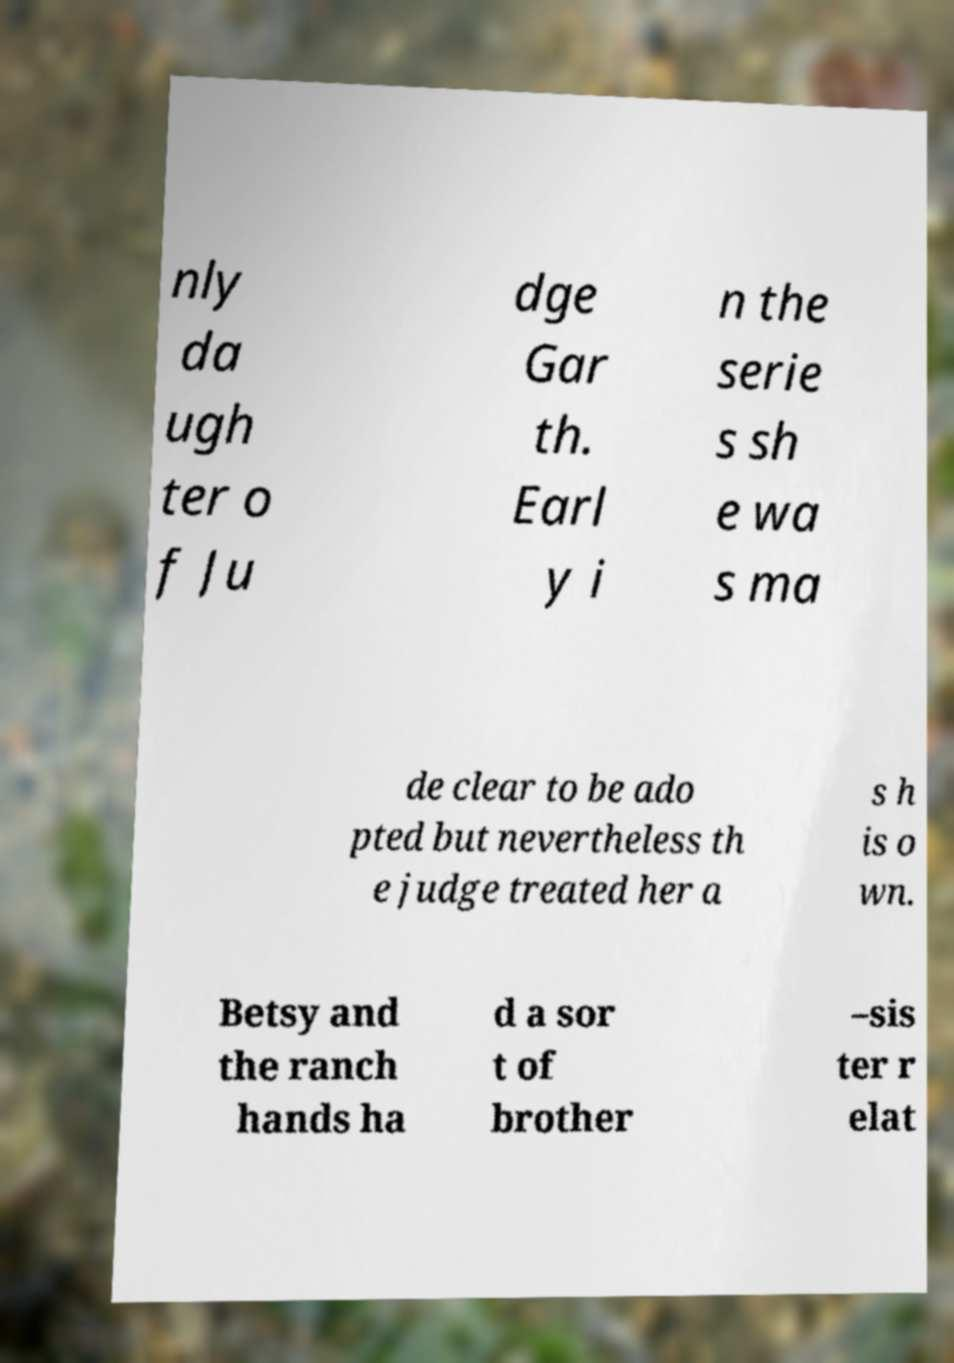Please read and relay the text visible in this image. What does it say? nly da ugh ter o f Ju dge Gar th. Earl y i n the serie s sh e wa s ma de clear to be ado pted but nevertheless th e judge treated her a s h is o wn. Betsy and the ranch hands ha d a sor t of brother –sis ter r elat 